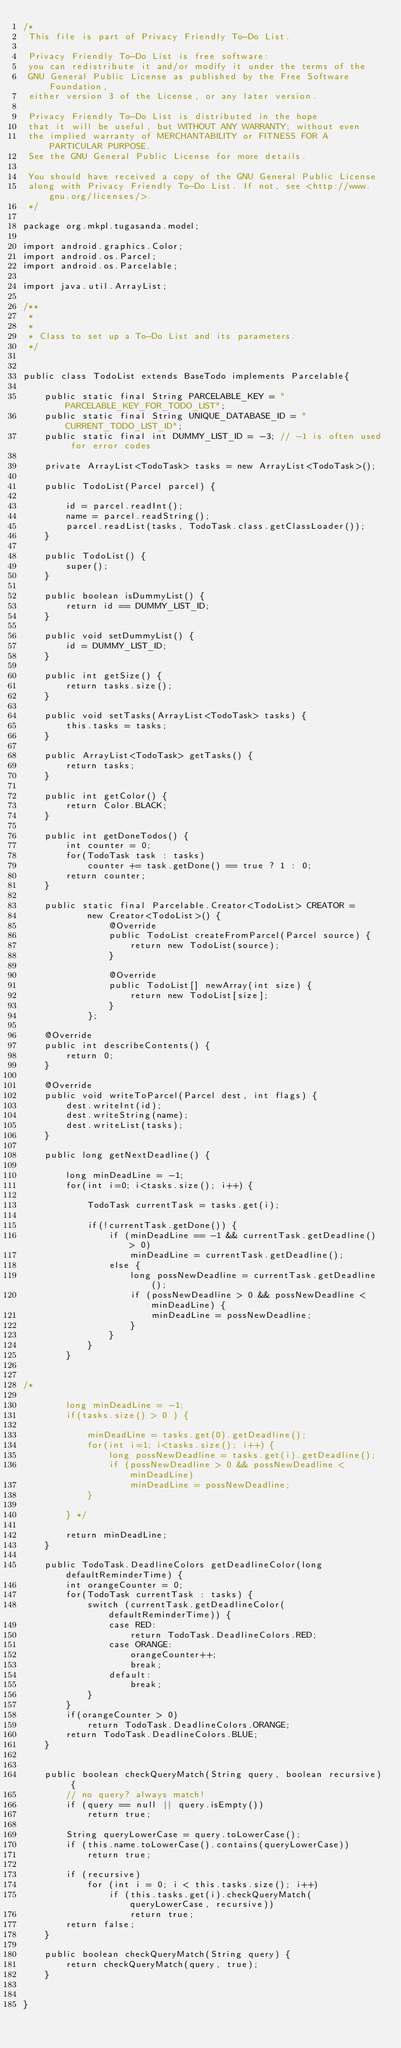Convert code to text. <code><loc_0><loc_0><loc_500><loc_500><_Java_>/*
 This file is part of Privacy Friendly To-Do List.

 Privacy Friendly To-Do List is free software:
 you can redistribute it and/or modify it under the terms of the
 GNU General Public License as published by the Free Software Foundation,
 either version 3 of the License, or any later version.

 Privacy Friendly To-Do List is distributed in the hope
 that it will be useful, but WITHOUT ANY WARRANTY; without even
 the implied warranty of MERCHANTABILITY or FITNESS FOR A PARTICULAR PURPOSE.
 See the GNU General Public License for more details.

 You should have received a copy of the GNU General Public License
 along with Privacy Friendly To-Do List. If not, see <http://www.gnu.org/licenses/>.
 */

package org.mkpl.tugasanda.model;

import android.graphics.Color;
import android.os.Parcel;
import android.os.Parcelable;

import java.util.ArrayList;

/**
 *
 *
 * Class to set up a To-Do List and its parameters.
 */


public class TodoList extends BaseTodo implements Parcelable{

    public static final String PARCELABLE_KEY = "PARCELABLE_KEY_FOR_TODO_LIST";
    public static final String UNIQUE_DATABASE_ID = "CURRENT_TODO_LIST_ID";
    public static final int DUMMY_LIST_ID = -3; // -1 is often used for error codes

    private ArrayList<TodoTask> tasks = new ArrayList<TodoTask>();

    public TodoList(Parcel parcel) {

        id = parcel.readInt();
        name = parcel.readString();
        parcel.readList(tasks, TodoTask.class.getClassLoader());
    }

    public TodoList() {
        super();
    }

    public boolean isDummyList() {
        return id == DUMMY_LIST_ID;
    }

    public void setDummyList() {
        id = DUMMY_LIST_ID;
    }

    public int getSize() {
        return tasks.size();
    }

    public void setTasks(ArrayList<TodoTask> tasks) {
        this.tasks = tasks;
    }

    public ArrayList<TodoTask> getTasks() {
        return tasks;
    }

    public int getColor() {
        return Color.BLACK;
    }

    public int getDoneTodos() {
        int counter = 0;
        for(TodoTask task : tasks)
            counter += task.getDone() == true ? 1 : 0;
        return counter;
    }

    public static final Parcelable.Creator<TodoList> CREATOR =
            new Creator<TodoList>() {
                @Override
                public TodoList createFromParcel(Parcel source) {
                    return new TodoList(source);
                }

                @Override
                public TodoList[] newArray(int size) {
                    return new TodoList[size];
                }
            };

    @Override
    public int describeContents() {
        return 0;
    }

    @Override
    public void writeToParcel(Parcel dest, int flags) {
        dest.writeInt(id);
        dest.writeString(name);
        dest.writeList(tasks);
    }

    public long getNextDeadline() {

        long minDeadLine = -1;
        for(int i=0; i<tasks.size(); i++) {

            TodoTask currentTask = tasks.get(i);

            if(!currentTask.getDone()) {
                if (minDeadLine == -1 && currentTask.getDeadline() > 0)
                    minDeadLine = currentTask.getDeadline();
                else {
                    long possNewDeadline = currentTask.getDeadline();
                    if (possNewDeadline > 0 && possNewDeadline < minDeadLine) {
                        minDeadLine = possNewDeadline;
                    }
                }
            }
        }


/*

        long minDeadLine = -1;
        if(tasks.size() > 0 ) {

            minDeadLine = tasks.get(0).getDeadline();
            for(int i=1; i<tasks.size(); i++) {
                long possNewDeadline = tasks.get(i).getDeadline();
                if (possNewDeadline > 0 && possNewDeadline < minDeadLine)
                    minDeadLine = possNewDeadline;
            }

        } */

        return minDeadLine;
    }

    public TodoTask.DeadlineColors getDeadlineColor(long defaultReminderTime) {
        int orangeCounter = 0;
        for(TodoTask currentTask : tasks) {
            switch (currentTask.getDeadlineColor(defaultReminderTime)) {
                case RED:
                    return TodoTask.DeadlineColors.RED;
                case ORANGE:
                    orangeCounter++;
                    break;
                default:
                    break;
            }
        }
        if(orangeCounter > 0)
            return TodoTask.DeadlineColors.ORANGE;
        return TodoTask.DeadlineColors.BLUE;
    }


    public boolean checkQueryMatch(String query, boolean recursive) {
        // no query? always match!
        if (query == null || query.isEmpty())
            return true;

        String queryLowerCase = query.toLowerCase();
        if (this.name.toLowerCase().contains(queryLowerCase))
            return true;

        if (recursive)
            for (int i = 0; i < this.tasks.size(); i++)
                if (this.tasks.get(i).checkQueryMatch(queryLowerCase, recursive))
                    return true;
        return false;
    }

    public boolean checkQueryMatch(String query) {
        return checkQueryMatch(query, true);
    }


}
</code> 